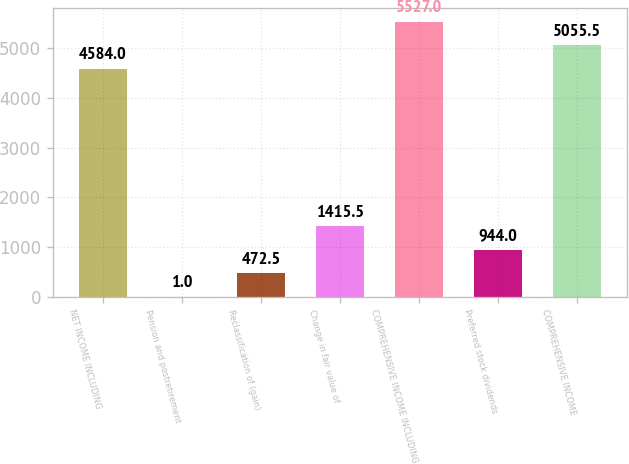Convert chart to OTSL. <chart><loc_0><loc_0><loc_500><loc_500><bar_chart><fcel>NET INCOME INCLUDING<fcel>Pension and postretirement<fcel>Reclassification of (gain)<fcel>Change in fair value of<fcel>COMPREHENSIVE INCOME INCLUDING<fcel>Preferred stock dividends<fcel>COMPREHENSIVE INCOME<nl><fcel>4584<fcel>1<fcel>472.5<fcel>1415.5<fcel>5527<fcel>944<fcel>5055.5<nl></chart> 